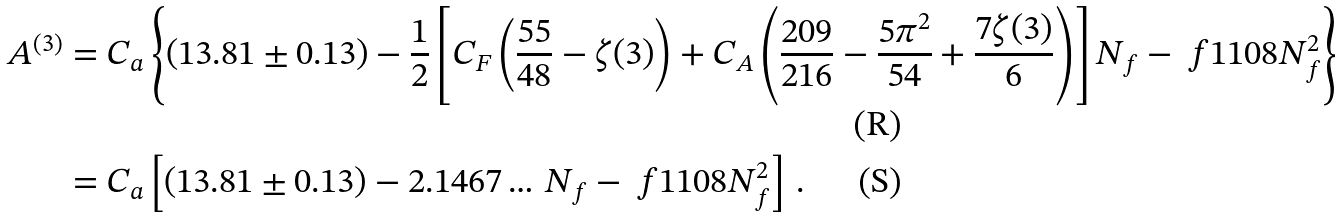<formula> <loc_0><loc_0><loc_500><loc_500>A ^ { ( 3 ) } & = C _ { a } \left \{ ( 1 3 . 8 1 \pm 0 . 1 3 ) - \frac { 1 } { 2 } \left [ C _ { F } \left ( \frac { 5 5 } { 4 8 } - \zeta ( 3 ) \right ) + C _ { A } \left ( \frac { 2 0 9 } { 2 1 6 } - \frac { 5 \pi ^ { 2 } } { 5 4 } + \frac { 7 \zeta ( 3 ) } { 6 } \right ) \right ] N _ { f } - \ f { 1 } { 1 0 8 } N _ { f } ^ { 2 } \right \} \\ & = C _ { a } \left [ ( 1 3 . 8 1 \pm 0 . 1 3 ) - 2 . 1 4 6 7 \dots \, N _ { f } - \ f { 1 } { 1 0 8 } N _ { f } ^ { 2 } \right ] \, .</formula> 